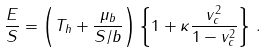Convert formula to latex. <formula><loc_0><loc_0><loc_500><loc_500>\frac { E } { S } = \left ( T _ { h } + \frac { \mu _ { b } } { S / b } \right ) \left \{ 1 + \kappa \frac { v _ { c } ^ { 2 } } { 1 - v _ { c } ^ { 2 } } \right \} \, .</formula> 